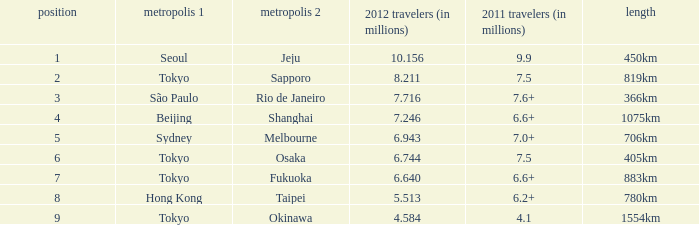In 2012, how many passengers (in millions) traveled through a route that spans 1075km? 7.246. 